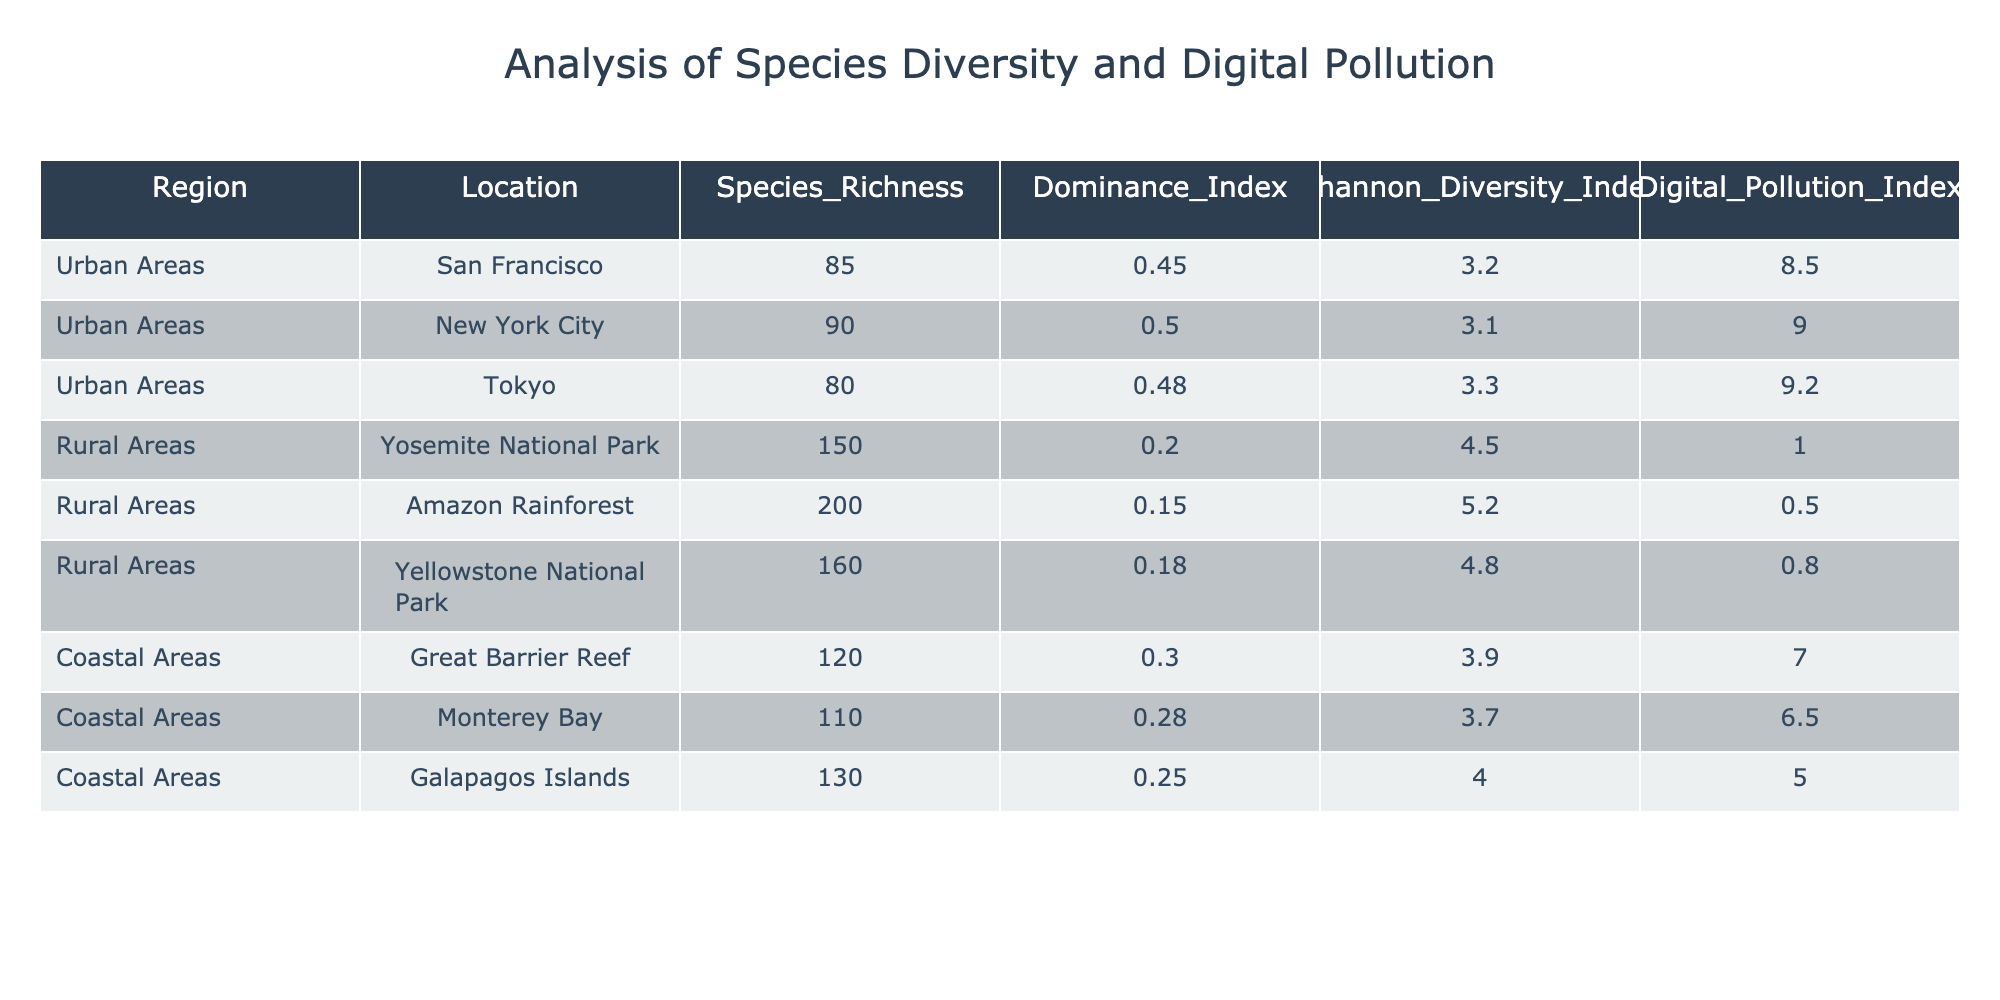What is the species richness in the Amazon Rainforest? The table shows the region "Rural Areas" with the location "Amazon Rainforest," where the species richness is specifically listed as 200.
Answer: 200 Which urban area has the highest dominance index? By examining the urban areas, the dominance indices for the cities are San Francisco (0.45), New York City (0.50), and Tokyo (0.48). The highest value among these is in New York City at 0.50.
Answer: New York City What is the average Shannon Diversity Index for coastal areas? For coastal areas, the Shannon Diversity Indices are: Great Barrier Reef (3.9), Monterey Bay (3.7), and Galapagos Islands (4.0). The average is calculated by summing these values (3.9 + 3.7 + 4.0 = 11.6) and dividing by the number of data points (3), resulting in 11.6 / 3 = 3.87.
Answer: 3.87 Is the Digital Pollution Index higher in urban areas compared to rural areas? The Digital Pollution Indices for urban areas are San Francisco (8.5), New York City (9.0), and Tokyo (9.2). For rural areas, they are Yosemite National Park (1.0), Amazon Rainforest (0.5), and Yellowstone National Park (0.8). All urban values are higher than the highest rural value (1.0), confirming that urban areas have a higher Digital Pollution Index.
Answer: Yes What is the difference in species richness between the Amazon Rainforest and Yellowstone National Park? The species richness for the Amazon Rainforest is 200, and for Yellowstone National Park, it is 160. The difference is calculated as 200 - 160 = 40.
Answer: 40 Which region has the lowest Dominance Index? Comparing the Dominance Indices, the lowest value is found in the Amazon Rainforest at 0.15.
Answer: Amazon Rainforest Is there a higher variability in Shannon Diversity Index in urban areas compared to coastal areas? The Shannon Diversity Indices for urban areas are 3.2, 3.1, and 3.3, while for coastal areas they are 3.9, 3.7, and 4.0. To assess variability, calculate the standard deviation or observe the range: Urban indices range from 3.1 to 3.3 (0.2) and coastal from 3.7 to 4.0 (0.3). Since the range in coastal areas (0.3) is higher than urban (0.2), coastal areas show more variability.
Answer: No Combined, what is the total species richness of all regions listed in the table? Summing the species richness values from all regions: 85 (San Francisco) + 90 (New York City) + 80 (Tokyo) + 150 (Yosemite) + 200 (Amazon) + 160 (Yellowstone) + 120 (Great Barrier Reef) + 110 (Monterey Bay) + 130 (Galapagos) = 1,125.
Answer: 1,125 What is the relationship between Digital Pollution Index and the Shannon Diversity Index in urban areas? In urban areas, the Digital Pollution Index shows an increasing trend (8.5, 9.0, 9.2) with a slight decrease in the Shannon Diversity Index (3.2, 3.1, 3.3). This could suggest a negative correlation; however, further statistical analysis would be needed to confirm the relationship.
Answer: Negative correlation suggested 